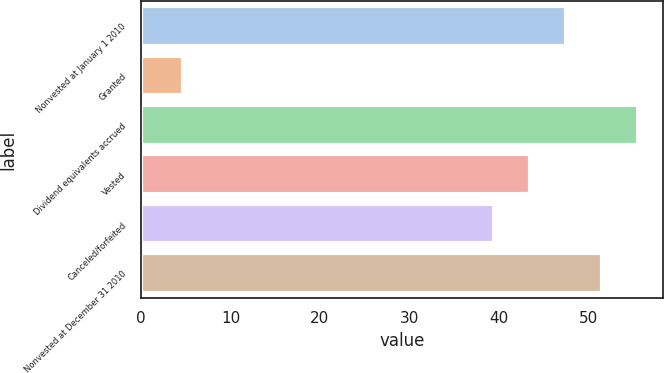Convert chart to OTSL. <chart><loc_0><loc_0><loc_500><loc_500><bar_chart><fcel>Nonvested at January 1 2010<fcel>Granted<fcel>Dividend equivalents accrued<fcel>Vested<fcel>Canceled/forfeited<fcel>Nonvested at December 31 2010<nl><fcel>47.51<fcel>4.71<fcel>55.53<fcel>43.5<fcel>39.49<fcel>51.52<nl></chart> 